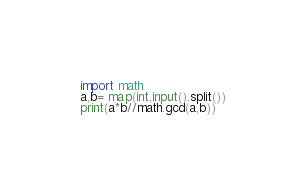Convert code to text. <code><loc_0><loc_0><loc_500><loc_500><_Python_>import math
a,b= map(int,input().split())
print(a*b//math.gcd(a,b))</code> 